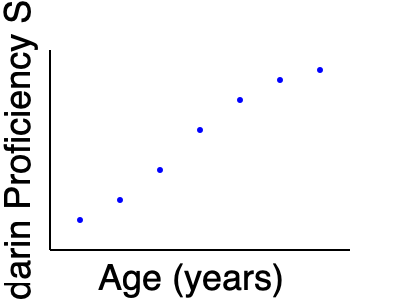Based on the scatter plot showing the relationship between a child's age and their Mandarin proficiency score, what type of correlation is observed, and what does this suggest about the optimal age for learning Mandarin? To answer this question, we need to analyze the scatter plot and interpret the relationship between age and Mandarin proficiency:

1. Observe the overall trend:
   The points in the scatter plot show a clear downward trend from left to right.

2. Identify the correlation type:
   As age increases (x-axis), the Mandarin proficiency score decreases (y-axis). This indicates a negative correlation.

3. Assess the strength of the correlation:
   The points form a relatively tight pattern around an imaginary line, suggesting a strong correlation.

4. Interpret the correlation:
   The strong negative correlation suggests that younger children tend to achieve higher Mandarin proficiency scores compared to older children.

5. Consider the implications for learning:
   This trend implies that there might be an advantage to starting Mandarin language learning at a younger age. The concept of a "critical period" in language acquisition supports this observation.

6. Optimal age for learning:
   Based on the scatter plot, the youngest age shown (around 5-6 years old) corresponds to the highest proficiency scores. This suggests that starting Mandarin education at or before this age might be optimal.

7. Limitations:
   It's important to note that correlation does not imply causation. Other factors not shown in this plot (e.g., learning environment, teaching methods) may also influence proficiency.
Answer: Strong negative correlation; suggests earlier start (around age 5-6) may be optimal for Mandarin learning. 